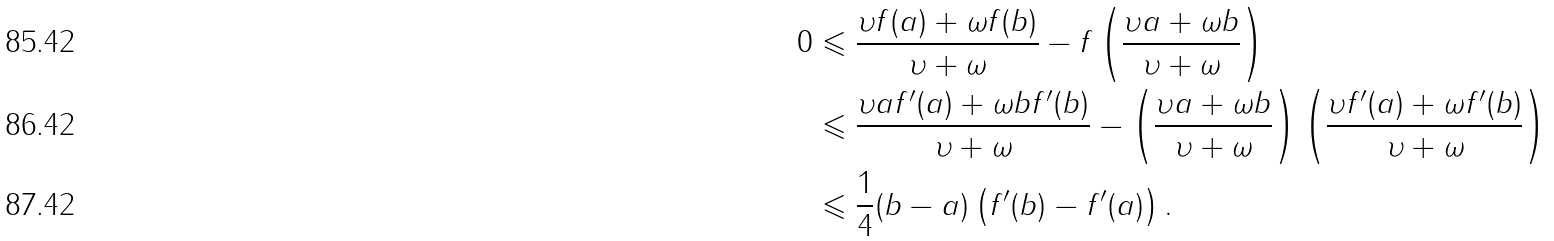Convert formula to latex. <formula><loc_0><loc_0><loc_500><loc_500>0 & \leqslant \frac { \upsilon f ( a ) + \omega f ( b ) } { \upsilon + \omega } - f \left ( { \frac { \upsilon a + \omega b } { \upsilon + \omega } } \right ) \\ & \leqslant \frac { \upsilon a { f } ^ { \prime } ( a ) + \omega b { f } ^ { \prime } ( b ) } { \upsilon + \omega } - \left ( { \frac { \upsilon a + \omega b } { \upsilon + \omega } } \right ) \left ( { \frac { \upsilon { f } ^ { \prime } ( a ) + \omega { f } ^ { \prime } ( b ) } { \upsilon + \omega } } \right ) \\ & \leqslant \frac { 1 } { 4 } ( b - a ) \left ( { { f } ^ { \prime } ( b ) - { f } ^ { \prime } ( a ) } \right ) .</formula> 